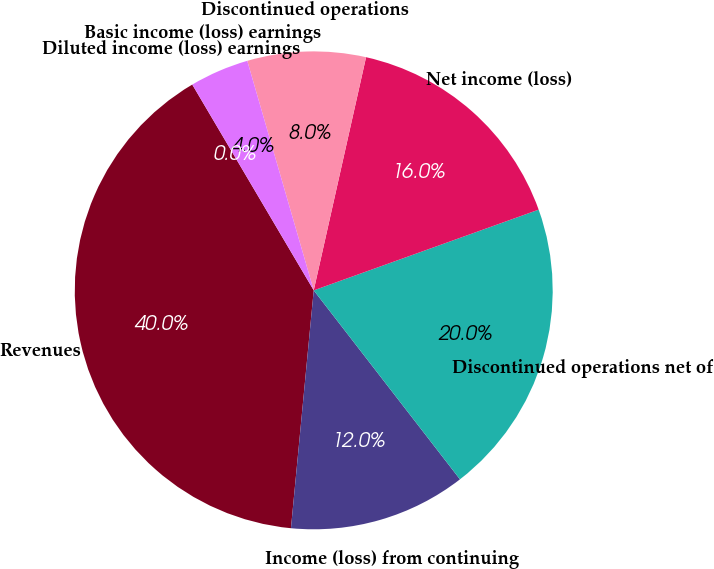Convert chart to OTSL. <chart><loc_0><loc_0><loc_500><loc_500><pie_chart><fcel>Revenues<fcel>Income (loss) from continuing<fcel>Discontinued operations net of<fcel>Net income (loss)<fcel>Discontinued operations<fcel>Basic income (loss) earnings<fcel>Diluted income (loss) earnings<nl><fcel>39.99%<fcel>12.0%<fcel>20.0%<fcel>16.0%<fcel>8.0%<fcel>4.0%<fcel>0.0%<nl></chart> 